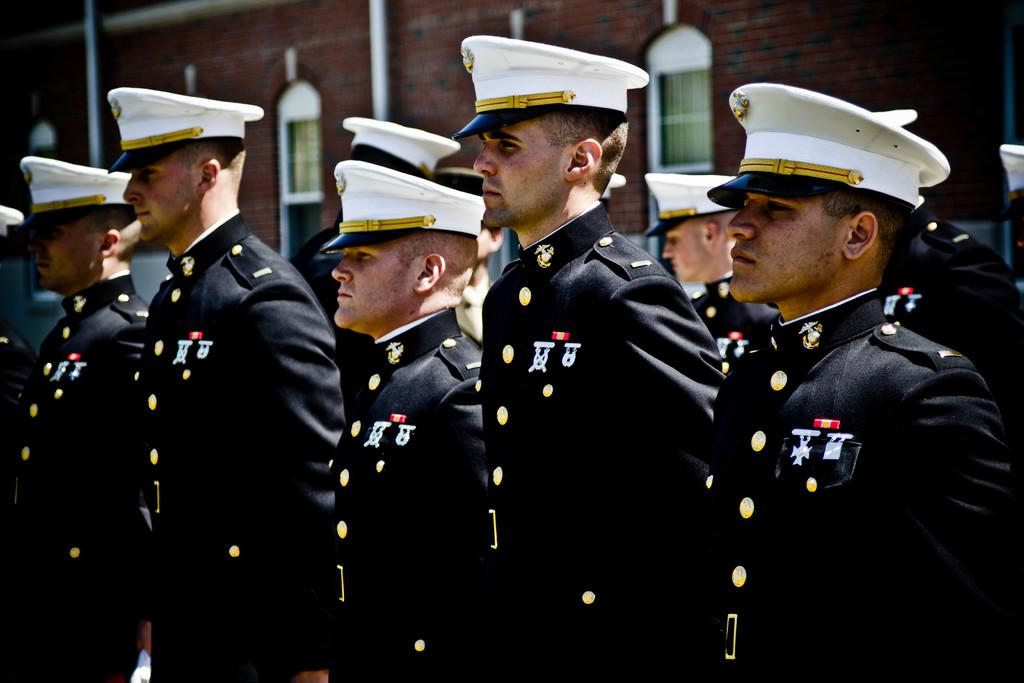What can be seen in the image? There are people standing in the image. What are the people wearing on their heads? The people are wearing caps. What is visible in the background of the image? There is a building in the background of the image. What feature of the building can be seen? There are windows visible on the building. What type of insurance do the people in the image have? There is no information about insurance in the image, as it only shows people standing and wearing caps. 